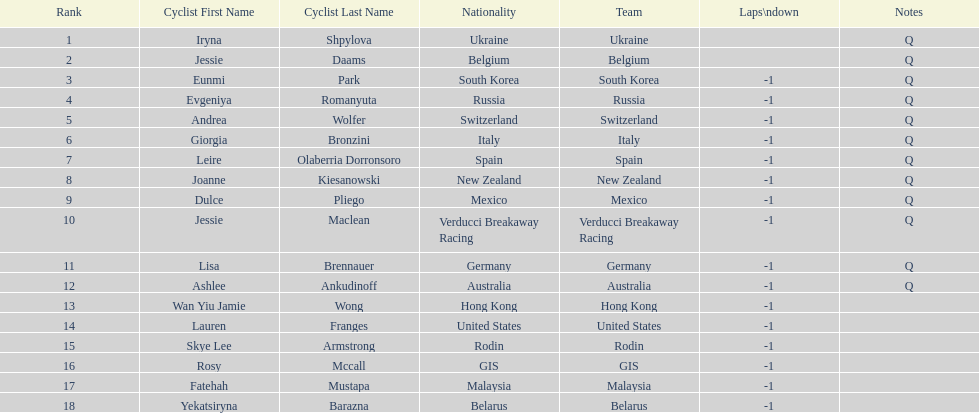What is the number rank of belgium? 2. 